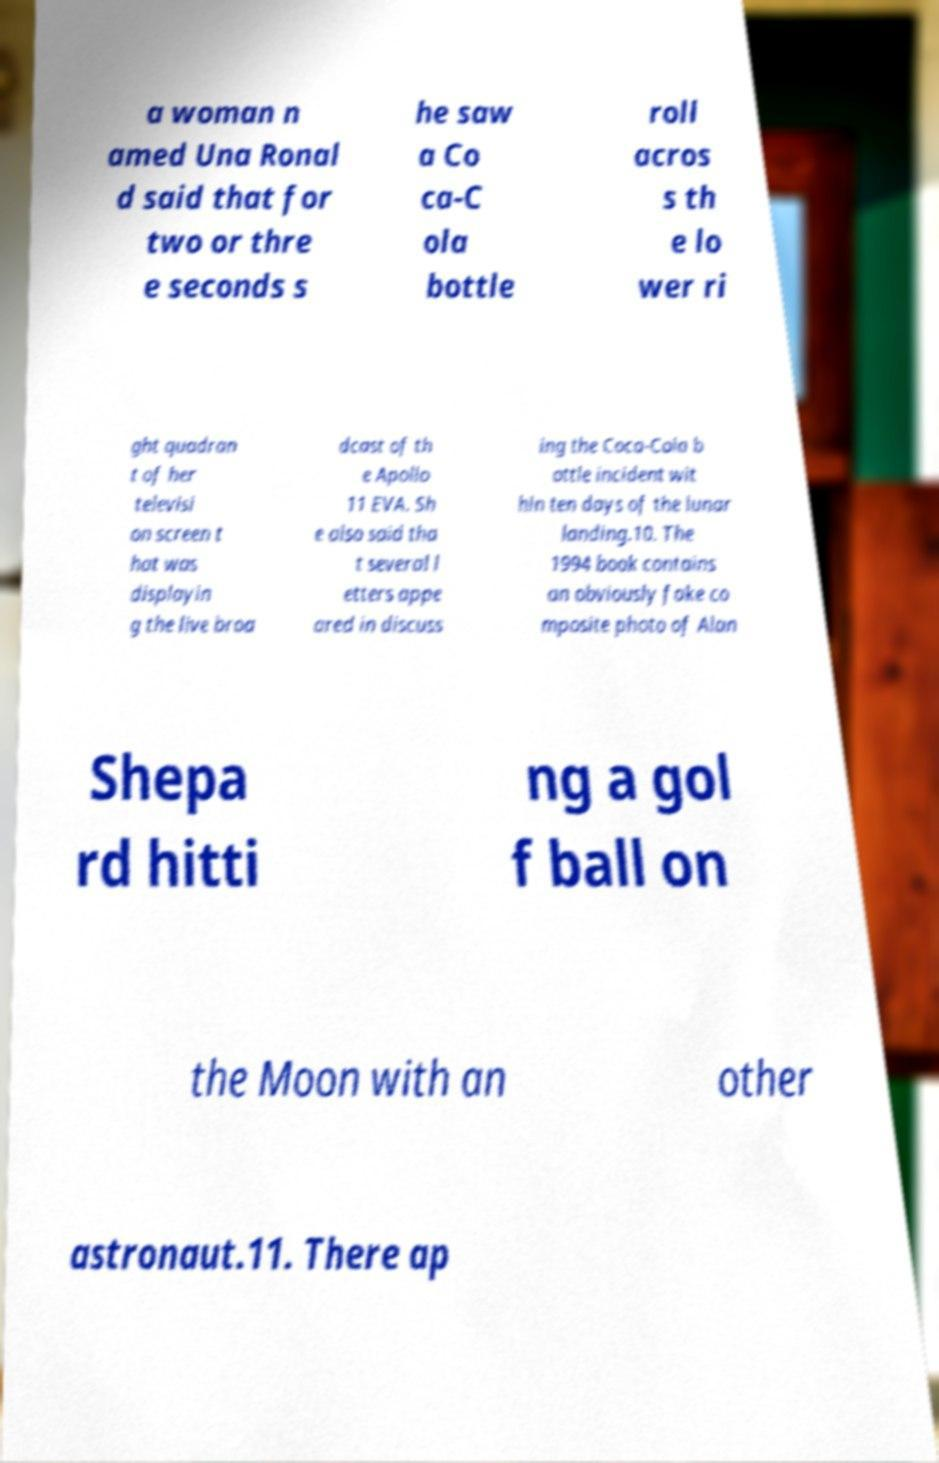There's text embedded in this image that I need extracted. Can you transcribe it verbatim? a woman n amed Una Ronal d said that for two or thre e seconds s he saw a Co ca-C ola bottle roll acros s th e lo wer ri ght quadran t of her televisi on screen t hat was displayin g the live broa dcast of th e Apollo 11 EVA. Sh e also said tha t several l etters appe ared in discuss ing the Coca-Cola b ottle incident wit hin ten days of the lunar landing.10. The 1994 book contains an obviously fake co mposite photo of Alan Shepa rd hitti ng a gol f ball on the Moon with an other astronaut.11. There ap 